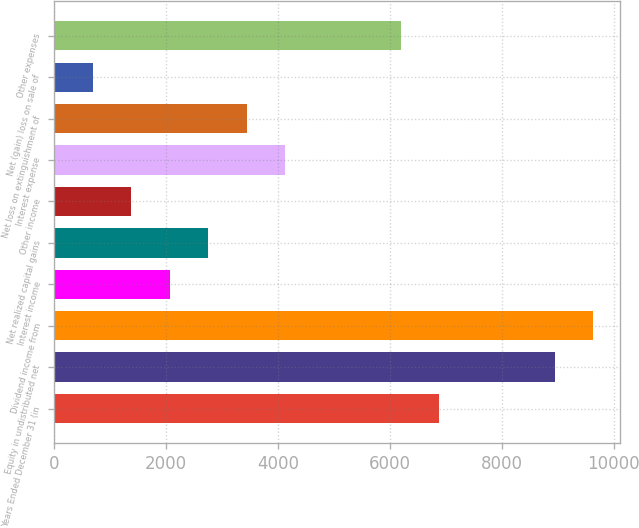Convert chart. <chart><loc_0><loc_0><loc_500><loc_500><bar_chart><fcel>Years Ended December 31 (in<fcel>Equity in undistributed net<fcel>Dividend income from<fcel>Interest income<fcel>Net realized capital gains<fcel>Other income<fcel>Interest expense<fcel>Net loss on extinguishment of<fcel>Net (gain) loss on sale of<fcel>Other expenses<nl><fcel>6883<fcel>8947.3<fcel>9635.4<fcel>2066.3<fcel>2754.4<fcel>1378.2<fcel>4130.6<fcel>3442.5<fcel>690.1<fcel>6194.9<nl></chart> 